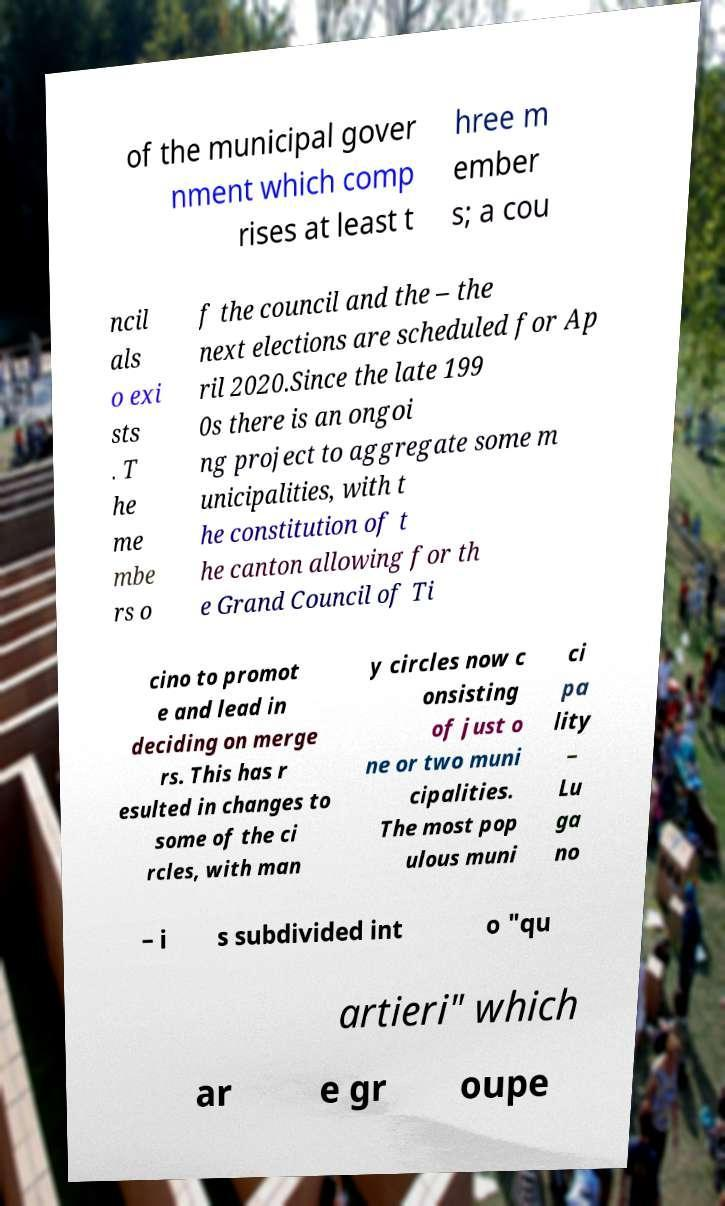Can you accurately transcribe the text from the provided image for me? of the municipal gover nment which comp rises at least t hree m ember s; a cou ncil als o exi sts . T he me mbe rs o f the council and the – the next elections are scheduled for Ap ril 2020.Since the late 199 0s there is an ongoi ng project to aggregate some m unicipalities, with t he constitution of t he canton allowing for th e Grand Council of Ti cino to promot e and lead in deciding on merge rs. This has r esulted in changes to some of the ci rcles, with man y circles now c onsisting of just o ne or two muni cipalities. The most pop ulous muni ci pa lity – Lu ga no – i s subdivided int o "qu artieri" which ar e gr oupe 